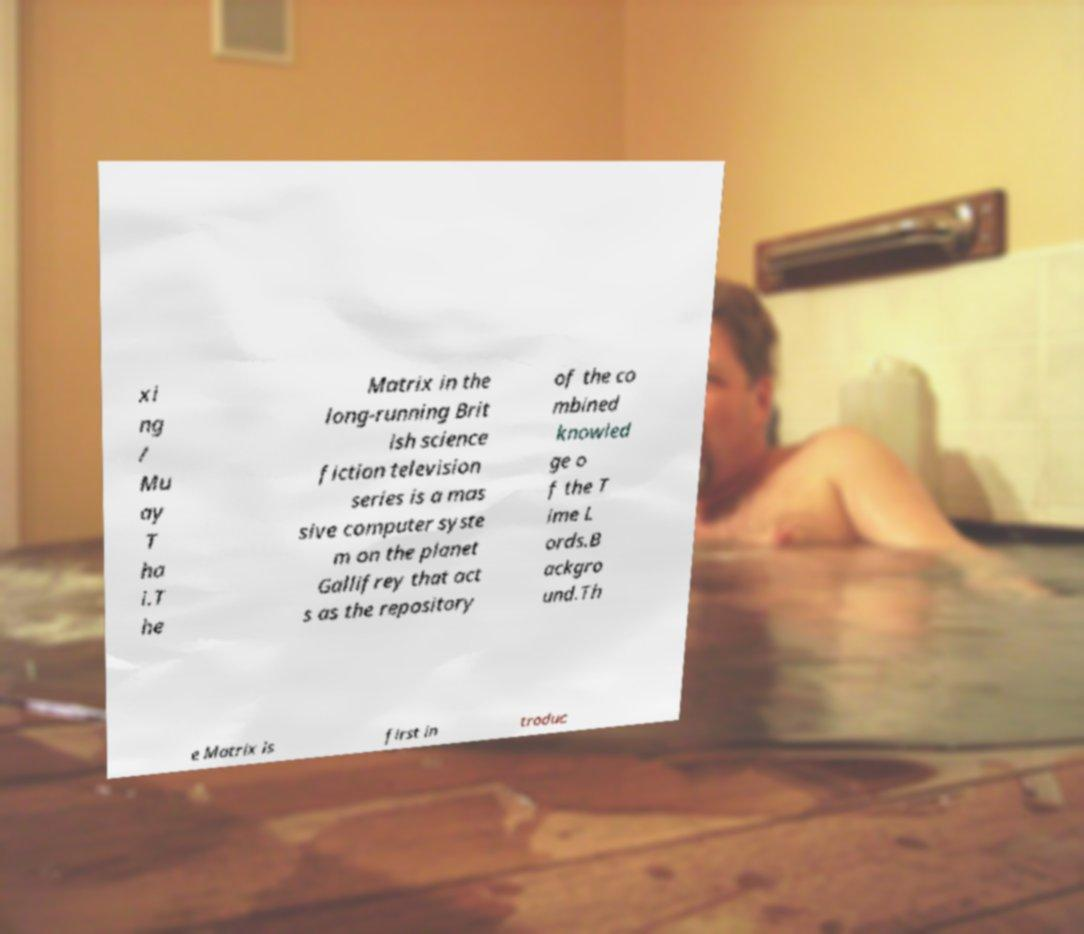What messages or text are displayed in this image? I need them in a readable, typed format. xi ng / Mu ay T ha i.T he Matrix in the long-running Brit ish science fiction television series is a mas sive computer syste m on the planet Gallifrey that act s as the repository of the co mbined knowled ge o f the T ime L ords.B ackgro und.Th e Matrix is first in troduc 